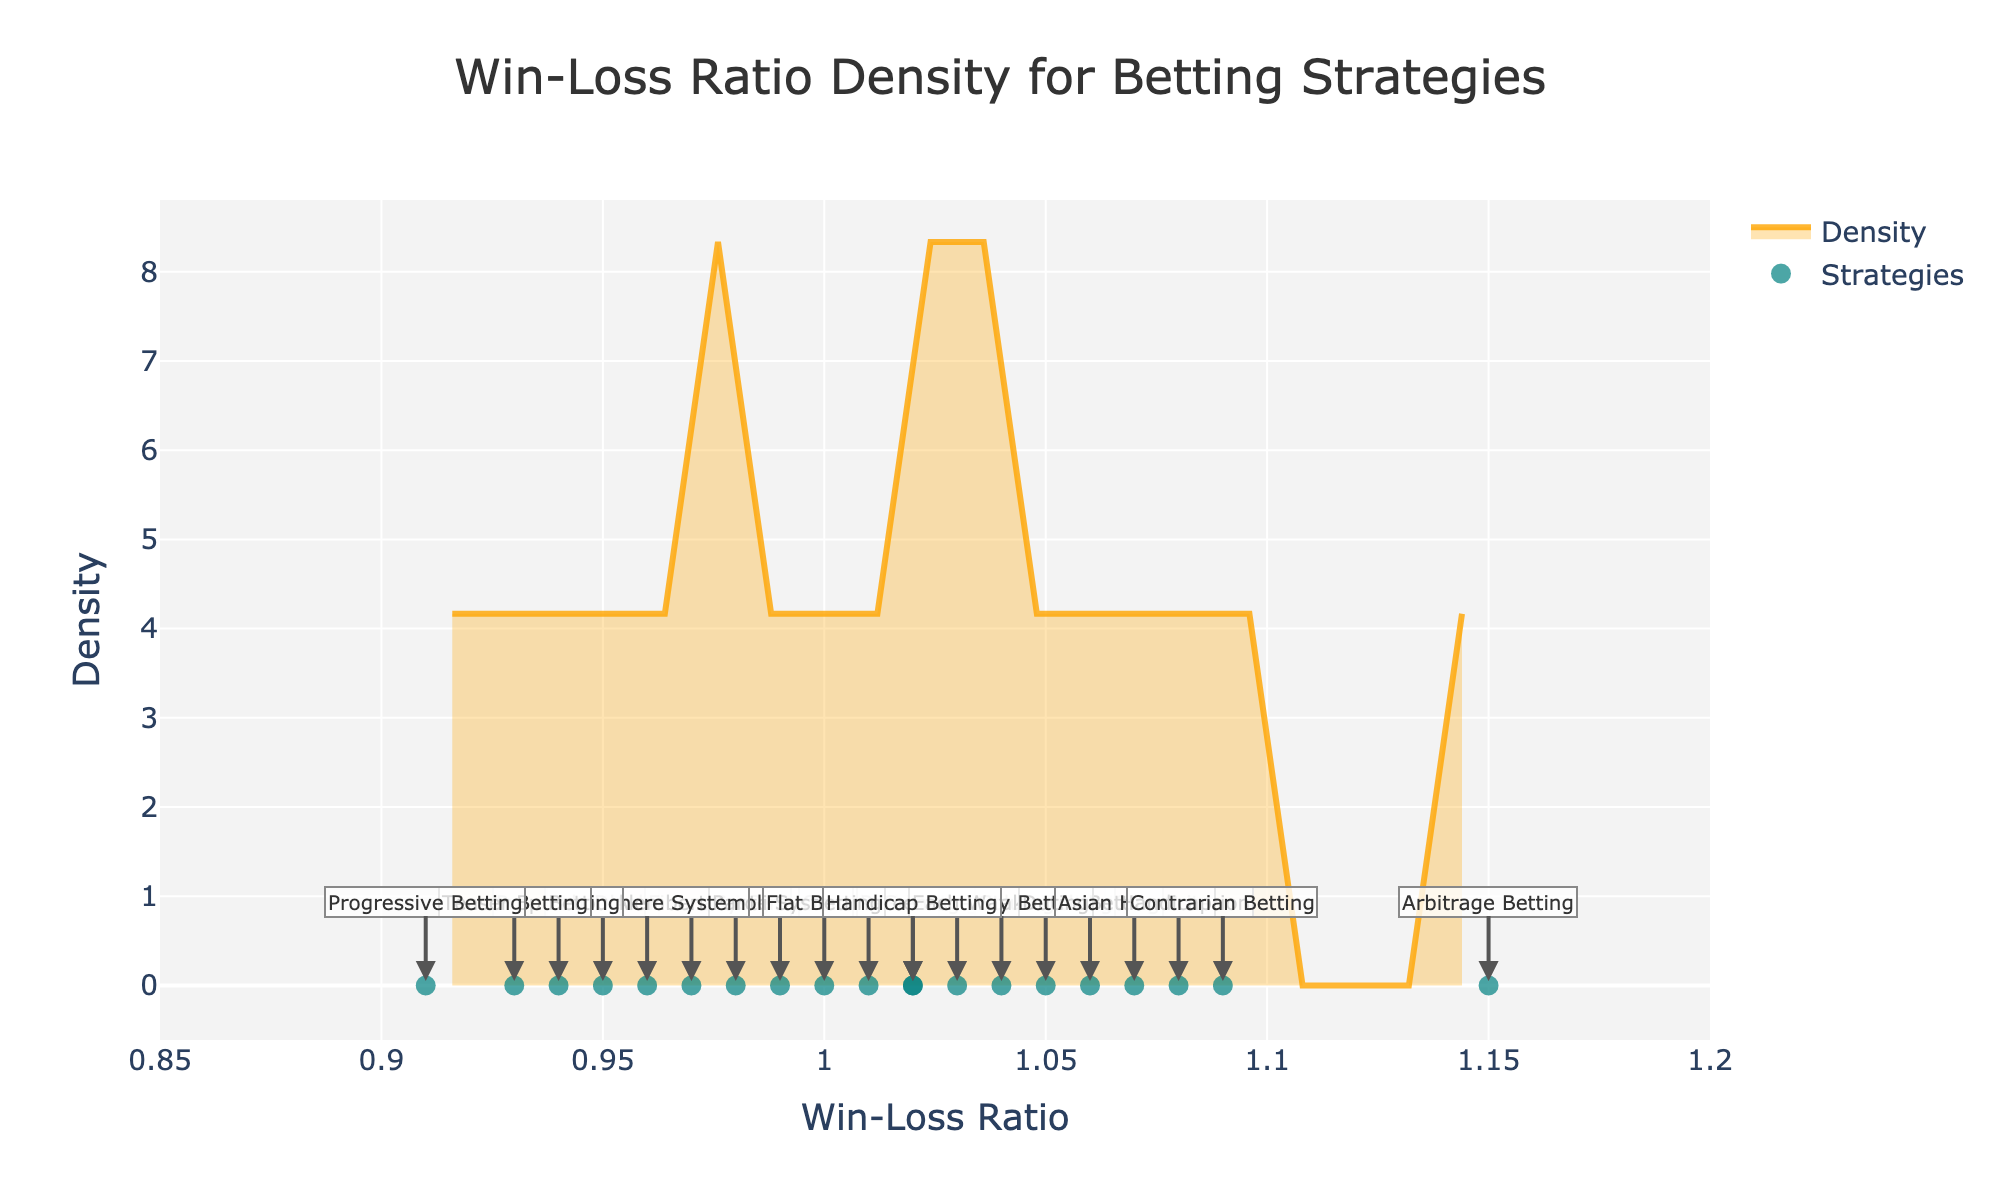What is the title of the plot? The title is located at the top center of the figure and is typically the largest text.
Answer: Win-Loss Ratio Density for Betting Strategies What is the highest win-loss ratio in the plot? By observing the x-axis values and the annotations for individual data points, the maximum win-loss ratio can be identified.
Answer: 1.15 How many betting strategies are plotted? Count the number of points or annotations along the x-axis in the figure.
Answer: 20 Which strategy has the lowest win-loss ratio? Look for the annotation with the lowest x-axis value.
Answer: Progressive Betting What is the range of win-loss ratios displayed on the x-axis? Check the minimum and maximum values shown on the x-axis.
Answer: 0.85 to 1.2 Which betting strategies have a win-loss ratio equal to 1.0? Identify the points or annotations along the x-axis corresponding to a win-loss ratio of 1.0.
Answer: Flat Betting How many strategies have win-loss ratios greater than or equal to 1.05? Count the number of annotations or points to the right of the 1.05 mark on the x-axis.
Answer: 7 Compare the win-loss ratio of Value Betting and Fixed Betting. Which one is higher? Check the positions of Value Betting and Fixed Betting annotations on the x-axis.
Answer: Value Betting What is the color used to fill the density plot? Observe the filled area under the curve for its color.
Answer: Orange Which strategy is plotted closest to a win-loss ratio of 1.03? Identify the point or annotation nearest to 1.03 on the x-axis.
Answer: Percentage Staking 